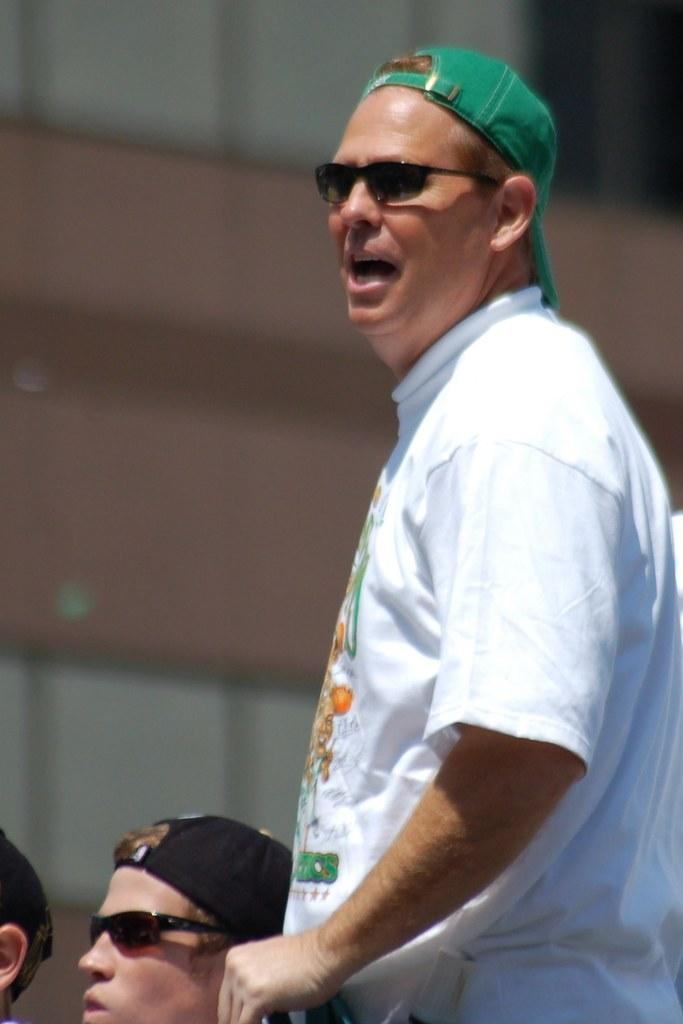Who or what can be seen in the image? There are people in the image. What is visible in the background of the image? There is a wall in the background of the image. What type of shoe is the brain wearing in the image? There is no brain or shoe present in the image; it features people and a wall in the background. 